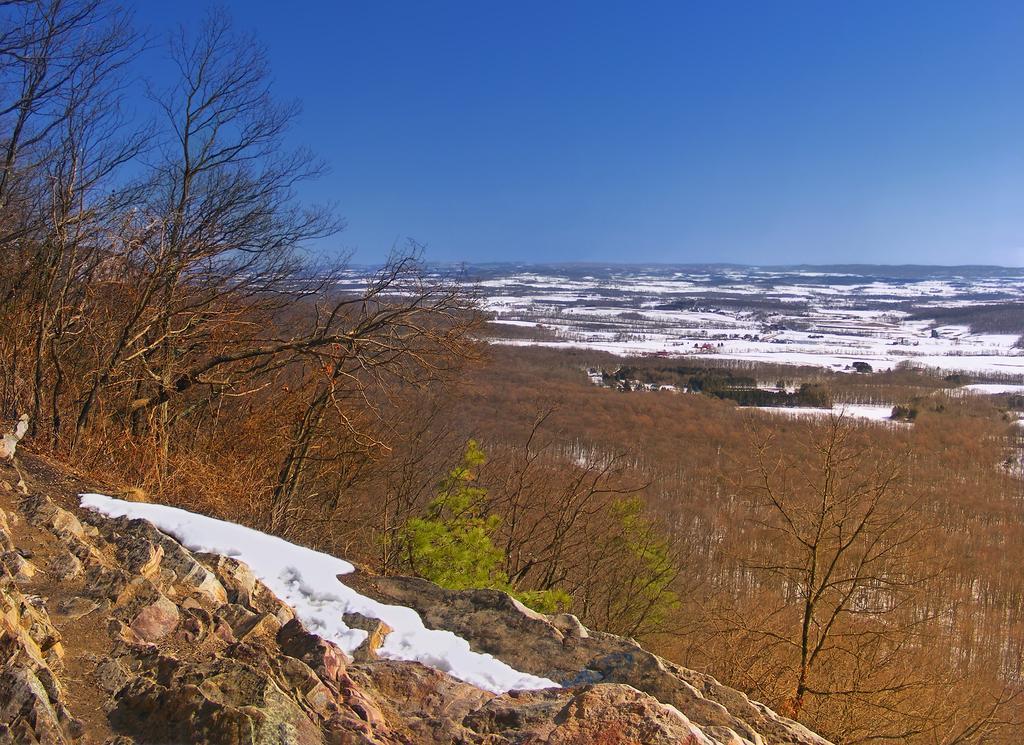Could you give a brief overview of what you see in this image? In this image in front there is a rock. In the background there are trees and sky. At the bottom of the image there is snow on the surface. 